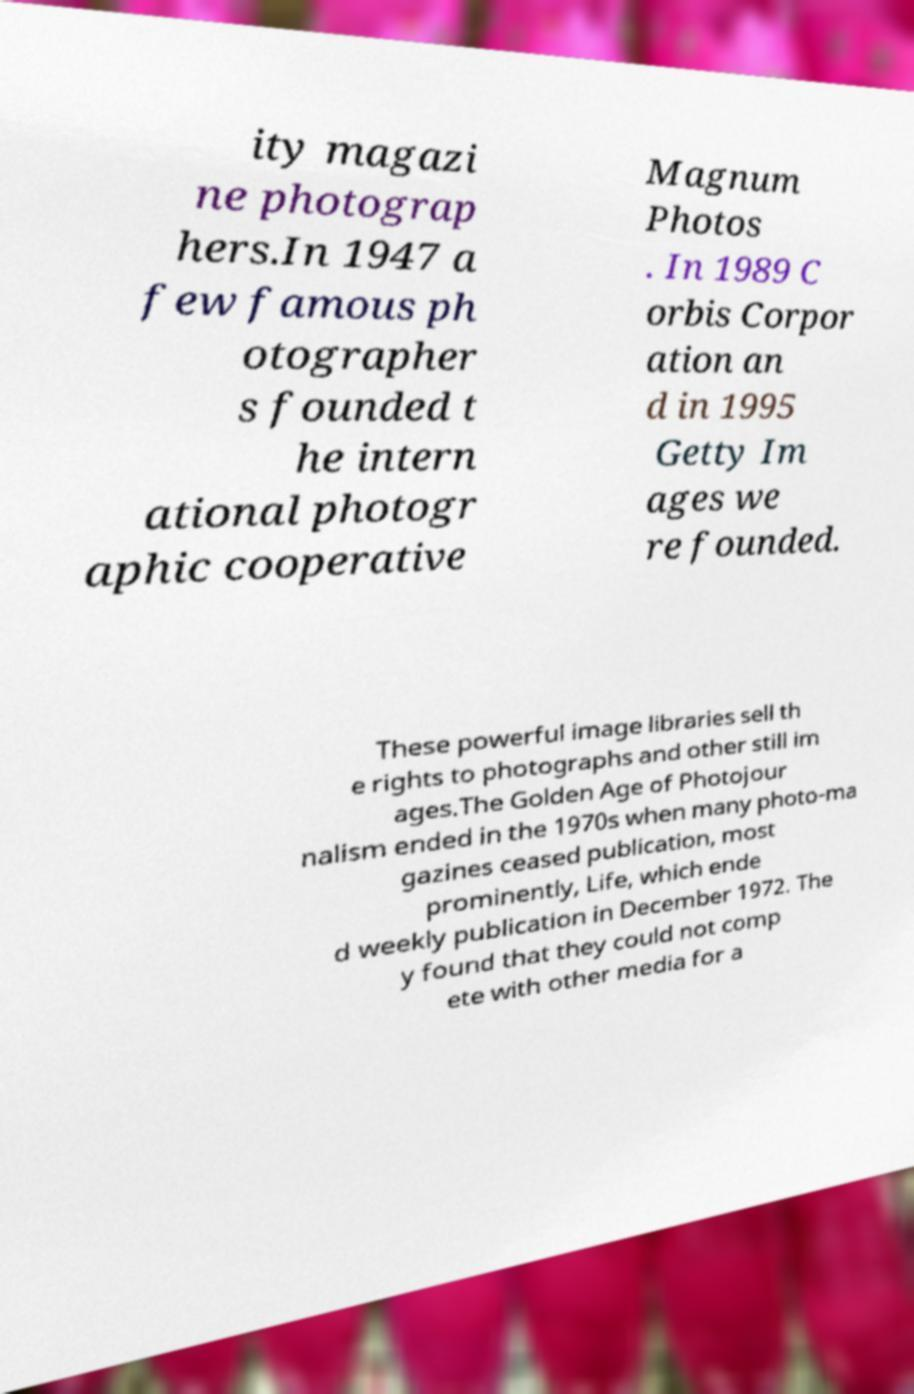Please read and relay the text visible in this image. What does it say? ity magazi ne photograp hers.In 1947 a few famous ph otographer s founded t he intern ational photogr aphic cooperative Magnum Photos . In 1989 C orbis Corpor ation an d in 1995 Getty Im ages we re founded. These powerful image libraries sell th e rights to photographs and other still im ages.The Golden Age of Photojour nalism ended in the 1970s when many photo-ma gazines ceased publication, most prominently, Life, which ende d weekly publication in December 1972. The y found that they could not comp ete with other media for a 